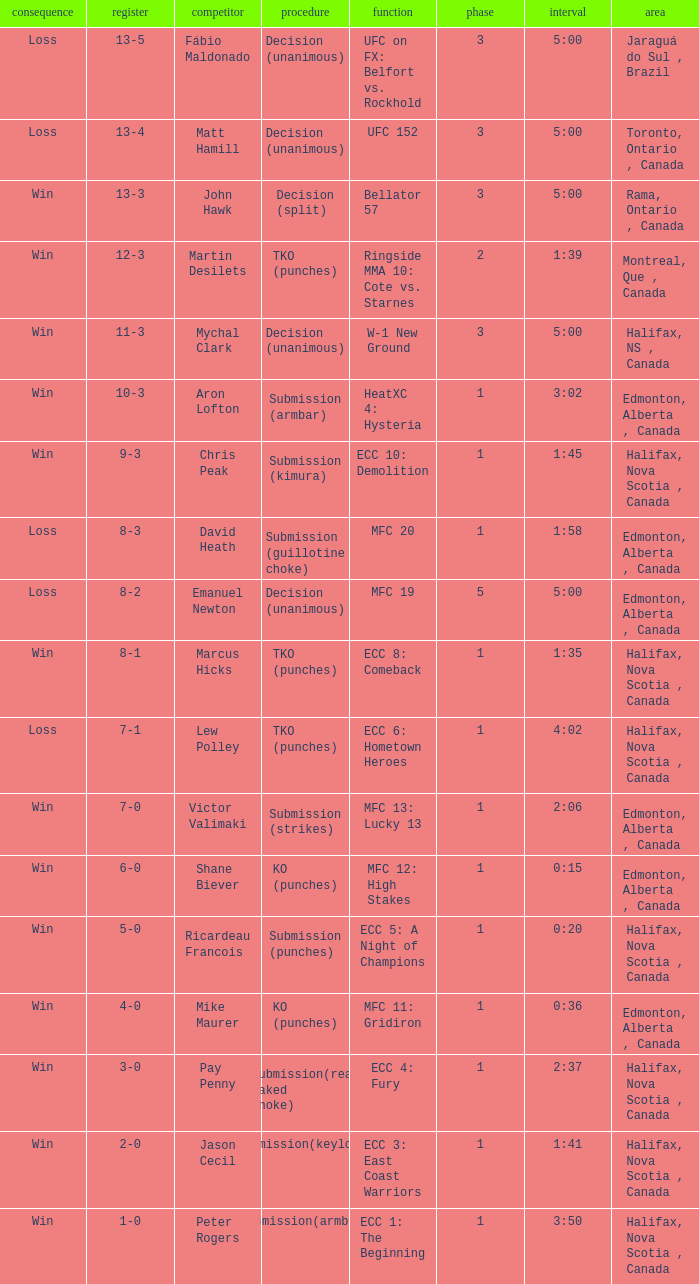What is the location of the match with Aron Lofton as the opponent? Edmonton, Alberta , Canada. 